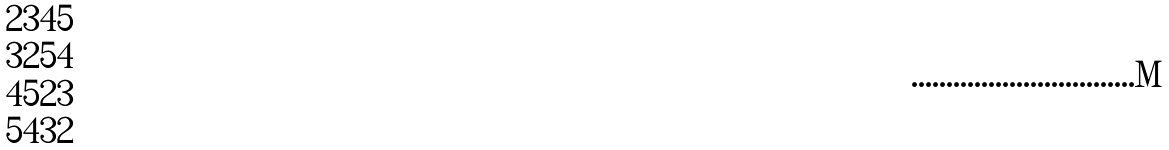<formula> <loc_0><loc_0><loc_500><loc_500>\begin{matrix} { 2 3 4 5 } \\ { 3 2 5 4 } \\ { 4 5 2 3 } \\ { 5 4 3 2 } \\ \end{matrix}</formula> 